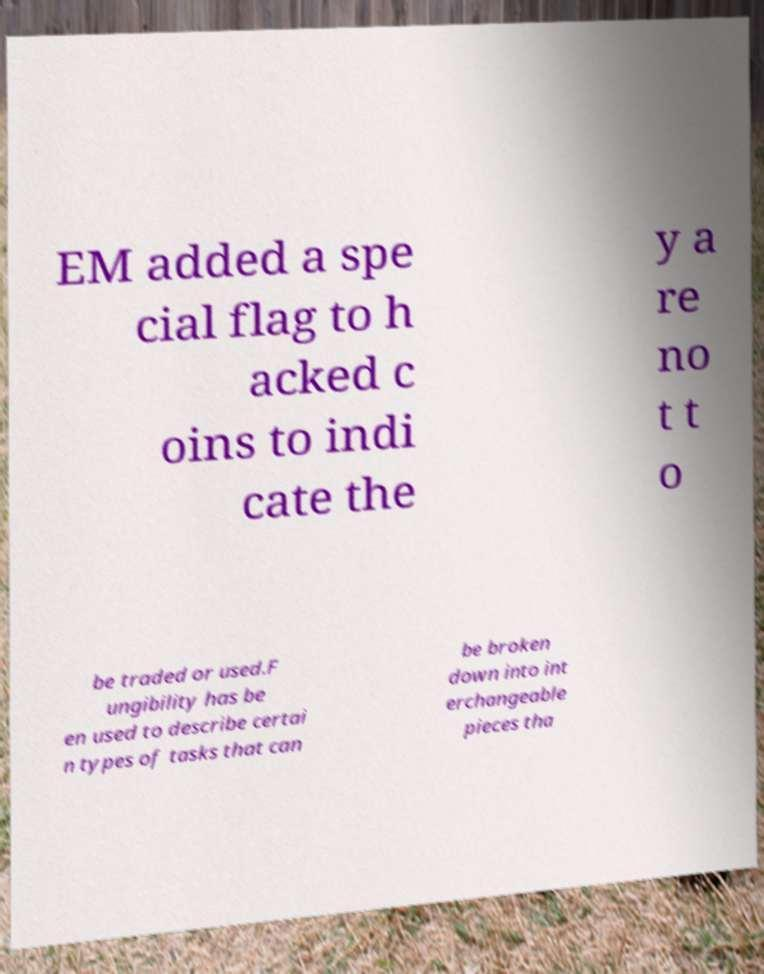What messages or text are displayed in this image? I need them in a readable, typed format. EM added a spe cial flag to h acked c oins to indi cate the y a re no t t o be traded or used.F ungibility has be en used to describe certai n types of tasks that can be broken down into int erchangeable pieces tha 